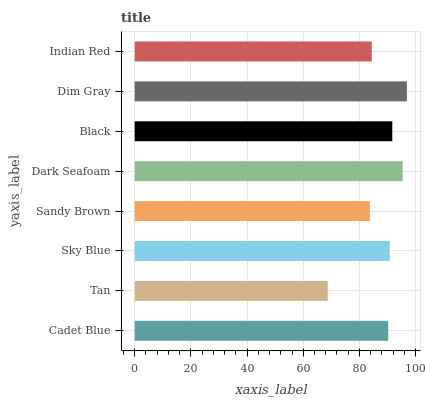Is Tan the minimum?
Answer yes or no. Yes. Is Dim Gray the maximum?
Answer yes or no. Yes. Is Sky Blue the minimum?
Answer yes or no. No. Is Sky Blue the maximum?
Answer yes or no. No. Is Sky Blue greater than Tan?
Answer yes or no. Yes. Is Tan less than Sky Blue?
Answer yes or no. Yes. Is Tan greater than Sky Blue?
Answer yes or no. No. Is Sky Blue less than Tan?
Answer yes or no. No. Is Sky Blue the high median?
Answer yes or no. Yes. Is Cadet Blue the low median?
Answer yes or no. Yes. Is Sandy Brown the high median?
Answer yes or no. No. Is Indian Red the low median?
Answer yes or no. No. 